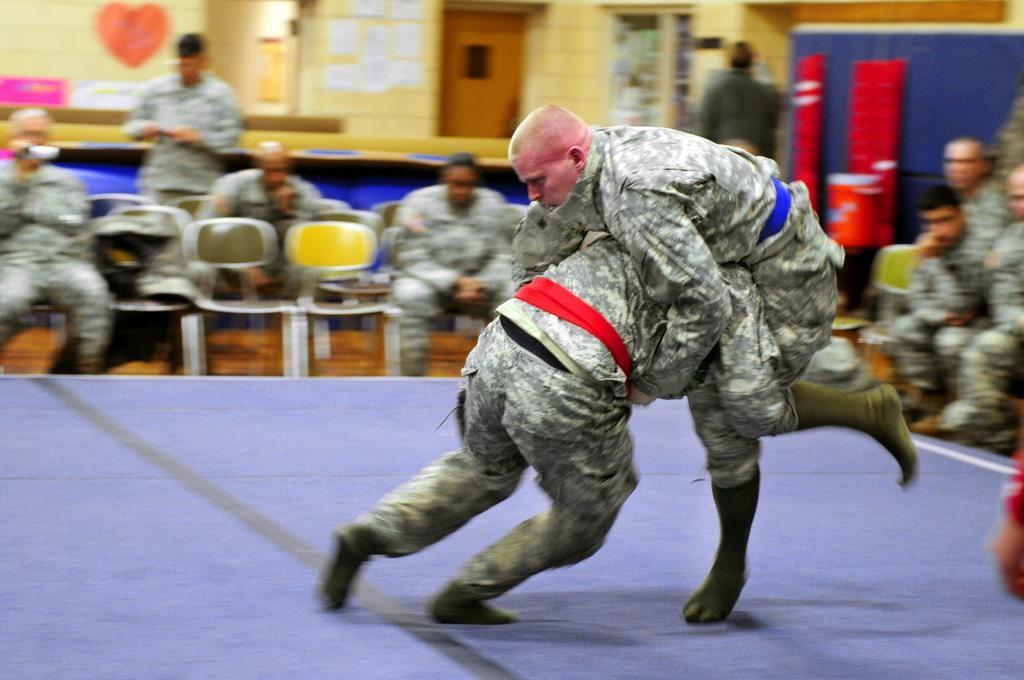Could you give a brief overview of what you see in this image? In this image I can see two people with the uniforms. To the side I can see the group of people with different color dresses. I can see one person is holding the camera. In the background I can see the door, wall and some boards can be seen. 